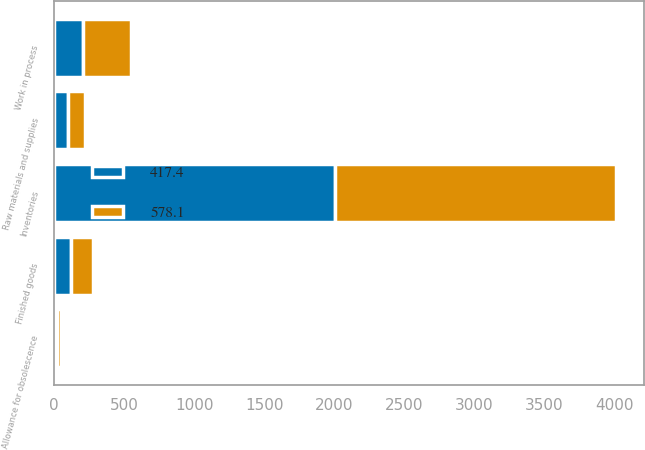Convert chart to OTSL. <chart><loc_0><loc_0><loc_500><loc_500><stacked_bar_chart><ecel><fcel>Inventories<fcel>Finished goods<fcel>Work in process<fcel>Raw materials and supplies<fcel>Allowance for obsolescence<nl><fcel>578.1<fcel>2004<fcel>151<fcel>337.9<fcel>115.6<fcel>26.4<nl><fcel>417.4<fcel>2003<fcel>124.6<fcel>211.3<fcel>102.9<fcel>21.4<nl></chart> 